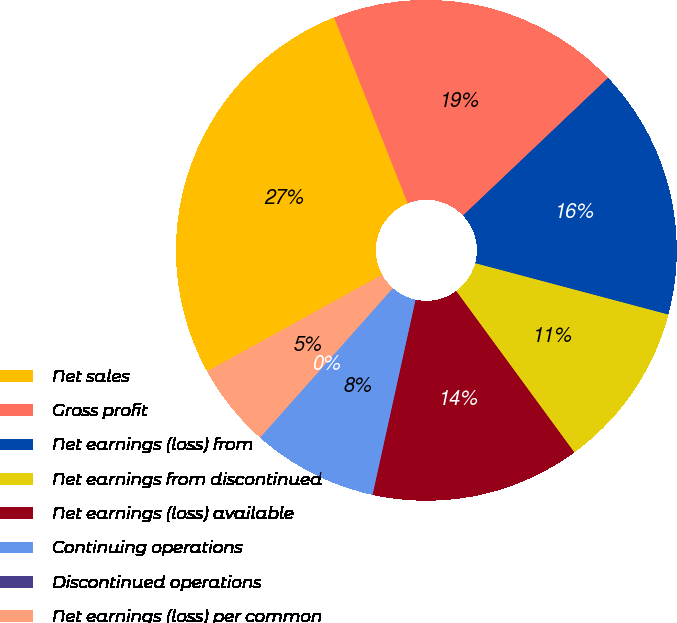Convert chart to OTSL. <chart><loc_0><loc_0><loc_500><loc_500><pie_chart><fcel>Net sales<fcel>Gross profit<fcel>Net earnings (loss) from<fcel>Net earnings from discontinued<fcel>Net earnings (loss) available<fcel>Continuing operations<fcel>Discontinued operations<fcel>Net earnings (loss) per common<nl><fcel>27.03%<fcel>18.92%<fcel>16.22%<fcel>10.81%<fcel>13.51%<fcel>8.11%<fcel>0.0%<fcel>5.41%<nl></chart> 